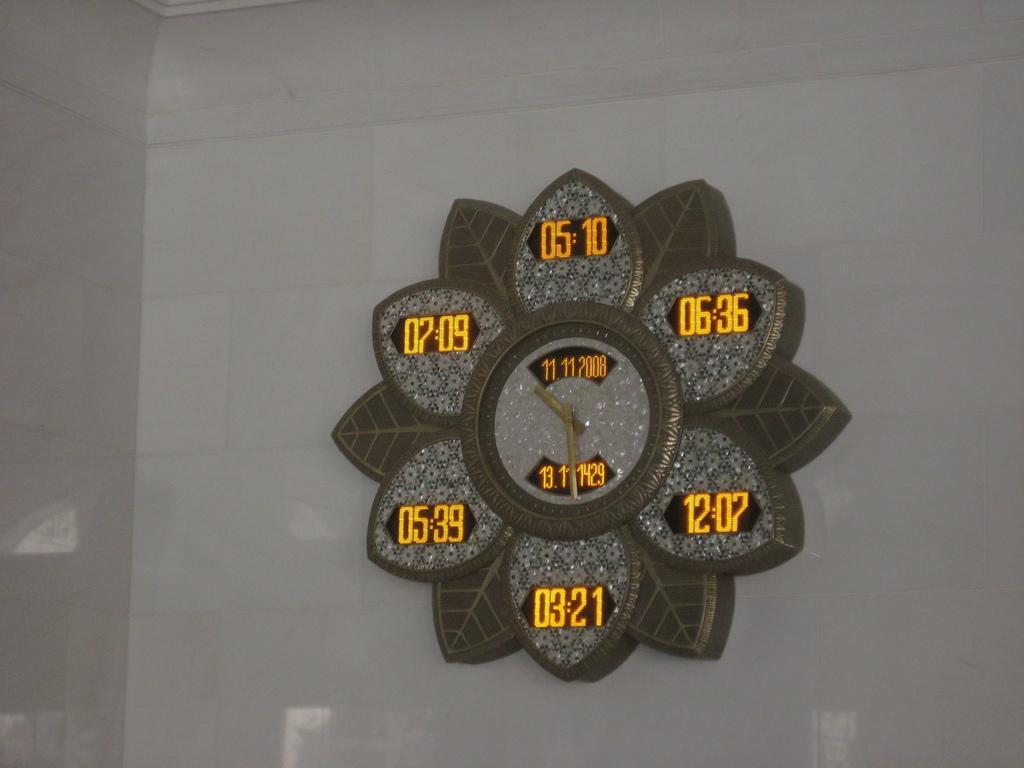Please provide a concise description of this image. In this image we can see a clock is attached to the white color wall. 